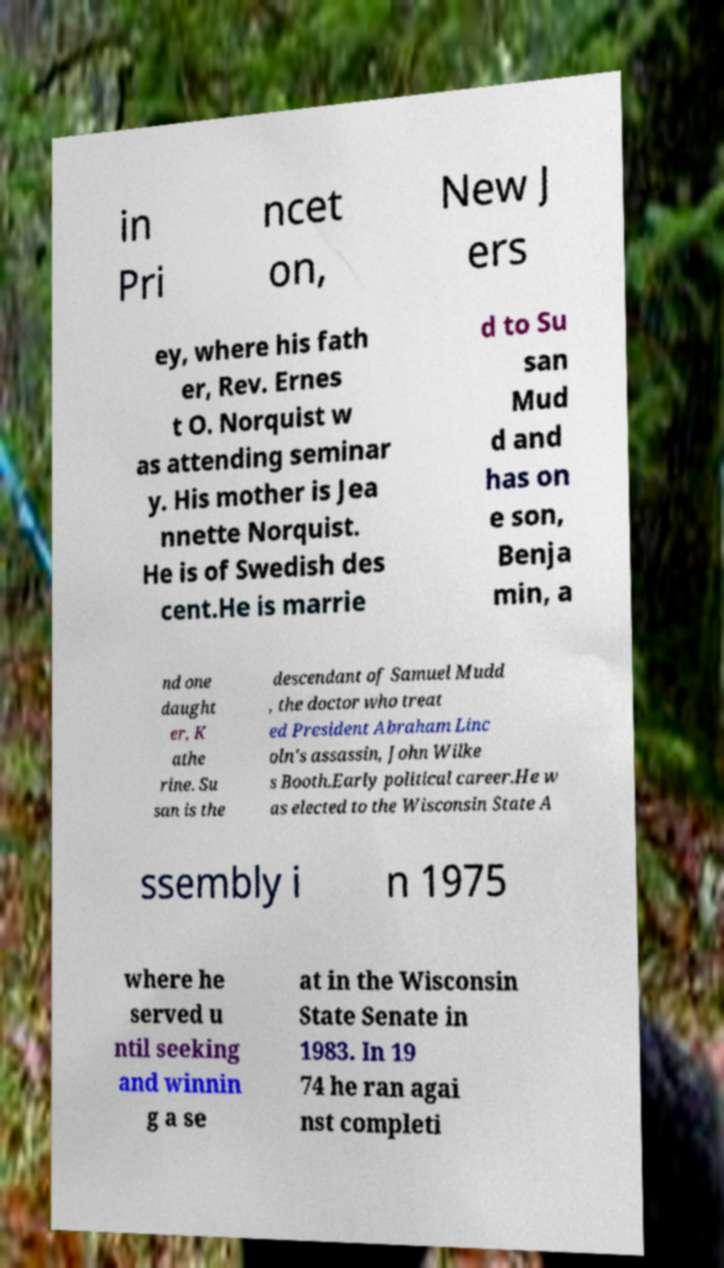Please read and relay the text visible in this image. What does it say? in Pri ncet on, New J ers ey, where his fath er, Rev. Ernes t O. Norquist w as attending seminar y. His mother is Jea nnette Norquist. He is of Swedish des cent.He is marrie d to Su san Mud d and has on e son, Benja min, a nd one daught er, K athe rine. Su san is the descendant of Samuel Mudd , the doctor who treat ed President Abraham Linc oln's assassin, John Wilke s Booth.Early political career.He w as elected to the Wisconsin State A ssembly i n 1975 where he served u ntil seeking and winnin g a se at in the Wisconsin State Senate in 1983. In 19 74 he ran agai nst completi 